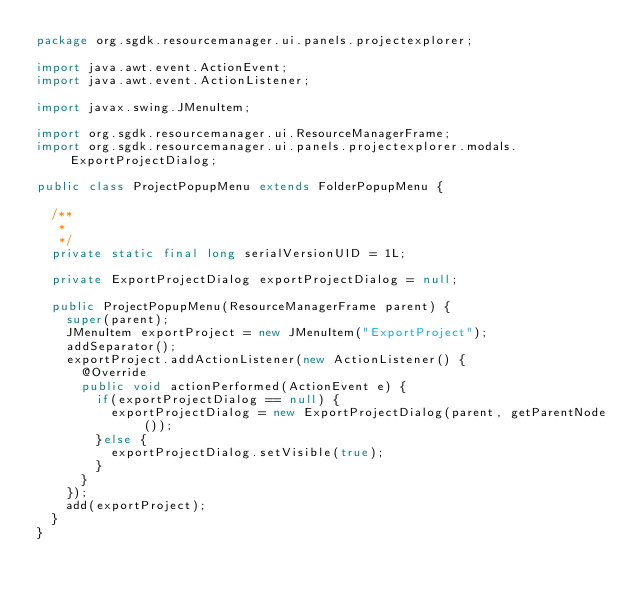Convert code to text. <code><loc_0><loc_0><loc_500><loc_500><_Java_>package org.sgdk.resourcemanager.ui.panels.projectexplorer;

import java.awt.event.ActionEvent;
import java.awt.event.ActionListener;

import javax.swing.JMenuItem;

import org.sgdk.resourcemanager.ui.ResourceManagerFrame;
import org.sgdk.resourcemanager.ui.panels.projectexplorer.modals.ExportProjectDialog;

public class ProjectPopupMenu extends FolderPopupMenu {

	/**
	 * 
	 */
	private static final long serialVersionUID = 1L;

	private ExportProjectDialog exportProjectDialog = null;
	
	public ProjectPopupMenu(ResourceManagerFrame parent) {
		super(parent);
		JMenuItem exportProject = new JMenuItem("ExportProject");		
		addSeparator();
		exportProject.addActionListener(new ActionListener() {			
			@Override
			public void actionPerformed(ActionEvent e) {
				if(exportProjectDialog == null) {
					exportProjectDialog = new ExportProjectDialog(parent, getParentNode());
				}else {
					exportProjectDialog.setVisible(true);
				}
			}
		});
		add(exportProject);
	}
}
</code> 